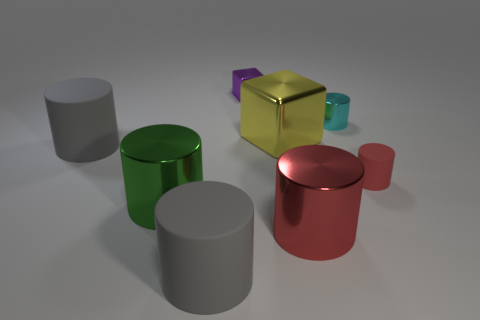Does the cube on the right side of the purple metallic thing have the same size as the cyan thing?
Your answer should be compact. No. What color is the rubber cylinder that is both to the left of the large red shiny cylinder and behind the green shiny cylinder?
Provide a succinct answer. Gray. There is a red thing that is behind the big red metallic object; what number of big cubes are in front of it?
Keep it short and to the point. 0. Is the shape of the small purple object the same as the yellow shiny object?
Provide a short and direct response. Yes. Is there anything else that has the same color as the small block?
Make the answer very short. No. There is a large red metal object; does it have the same shape as the tiny metal object that is to the right of the tiny purple shiny block?
Offer a terse response. Yes. There is a large metallic cylinder on the left side of the large gray object that is in front of the gray cylinder left of the green thing; what color is it?
Your answer should be compact. Green. Is there any other thing that has the same material as the yellow block?
Ensure brevity in your answer.  Yes. There is a small shiny thing that is in front of the purple metallic block; does it have the same shape as the red shiny object?
Your answer should be very brief. Yes. What is the small cyan object made of?
Offer a terse response. Metal. 